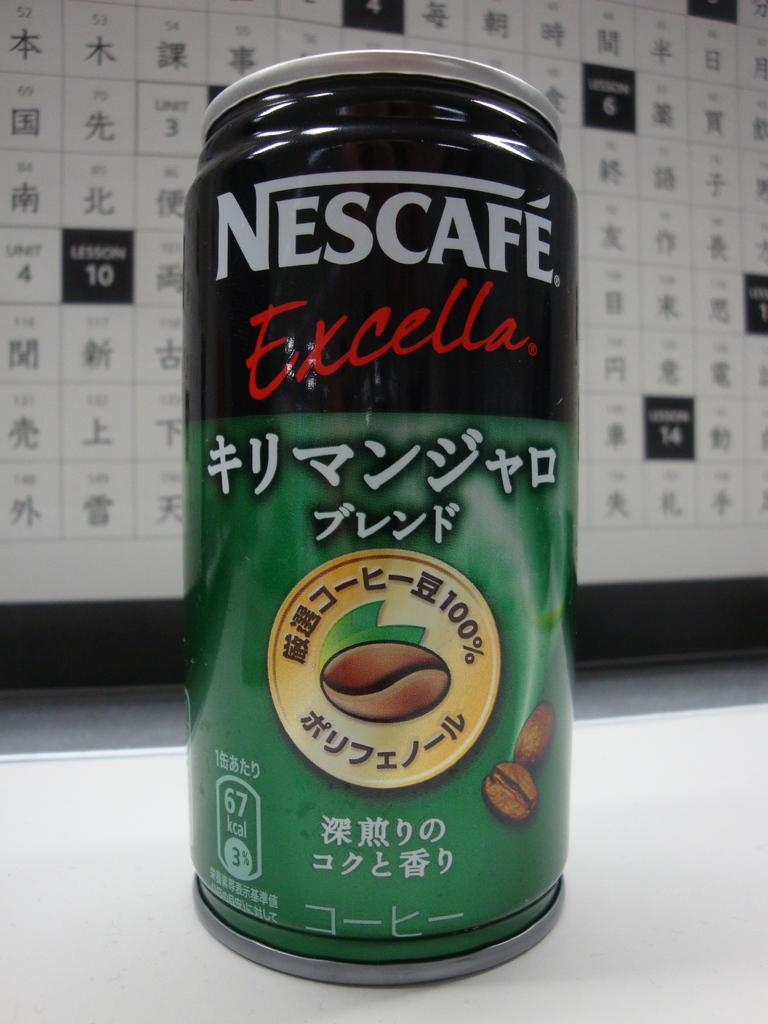Provide a one-sentence caption for the provided image. A can of Nescafe Excella also has writing in another language. 